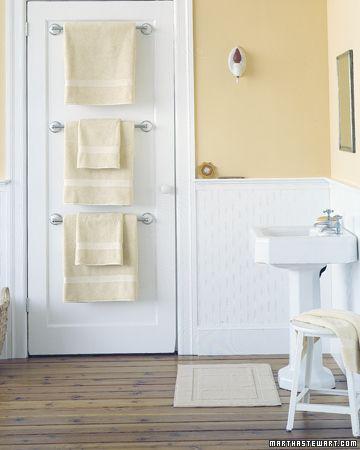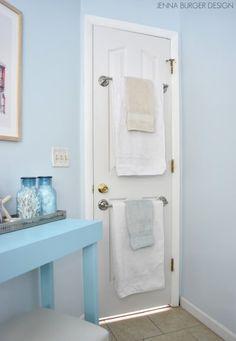The first image is the image on the left, the second image is the image on the right. For the images displayed, is the sentence "The left and right image contains the same number of metal racks that can hold towels." factually correct? Answer yes or no. No. The first image is the image on the left, the second image is the image on the right. Examine the images to the left and right. Is the description "Each image features an over-the-door chrome towel bar with at least 3 bars and at least one hanging towel." accurate? Answer yes or no. No. 